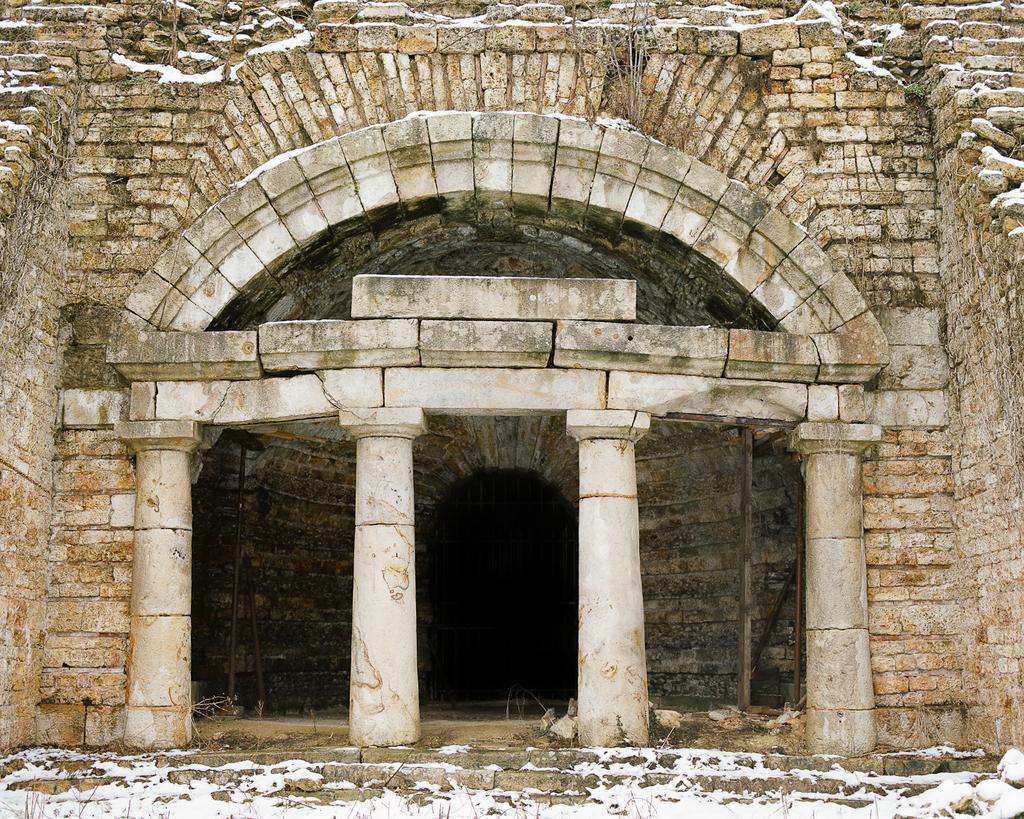What type of structure is present in the image? There is a building in the image. What architectural features can be seen on the building? The building has pillars. What material is used for the construction of the building? The building has stones. What other objects are visible in the image? There are poles and dried plants in the image. What type of plastic apparel is being worn by the building in the image? There is no plastic apparel present in the image, as the subject is a building and not a person. Additionally, buildings do not wear apparel. 